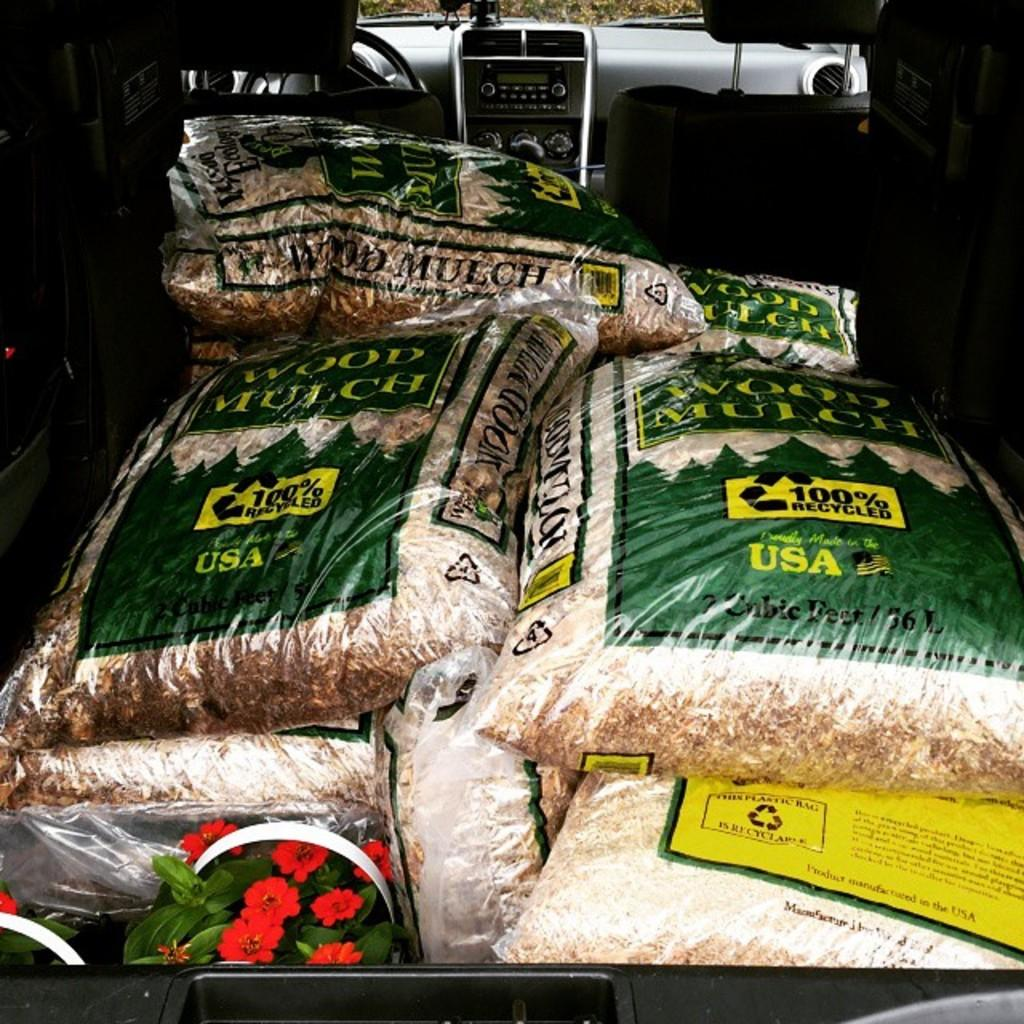What objects can be seen inside the vehicle? There are bags and flower pots in the vehicle. Can you describe the contents of the bags? The facts provided do not give information about the contents of the bags. What might the purpose of the flower pots be in the vehicle? The flower pots might be for transporting plants or for decoration. What type of wood can be seen in the vehicle? There is no wood present in the vehicle; the image only shows bags and flower pots. 